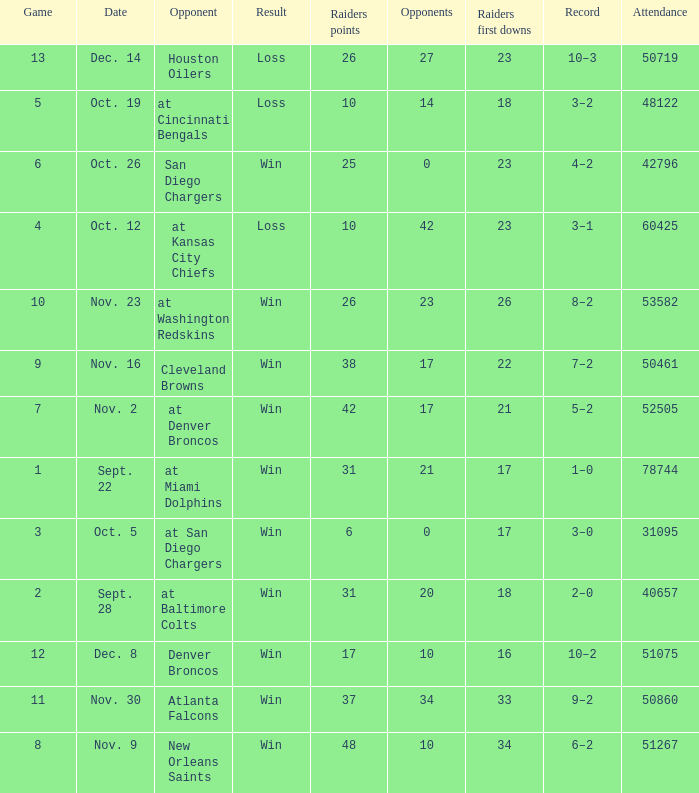Who was the game attended by 60425 people played against? At kansas city chiefs. 